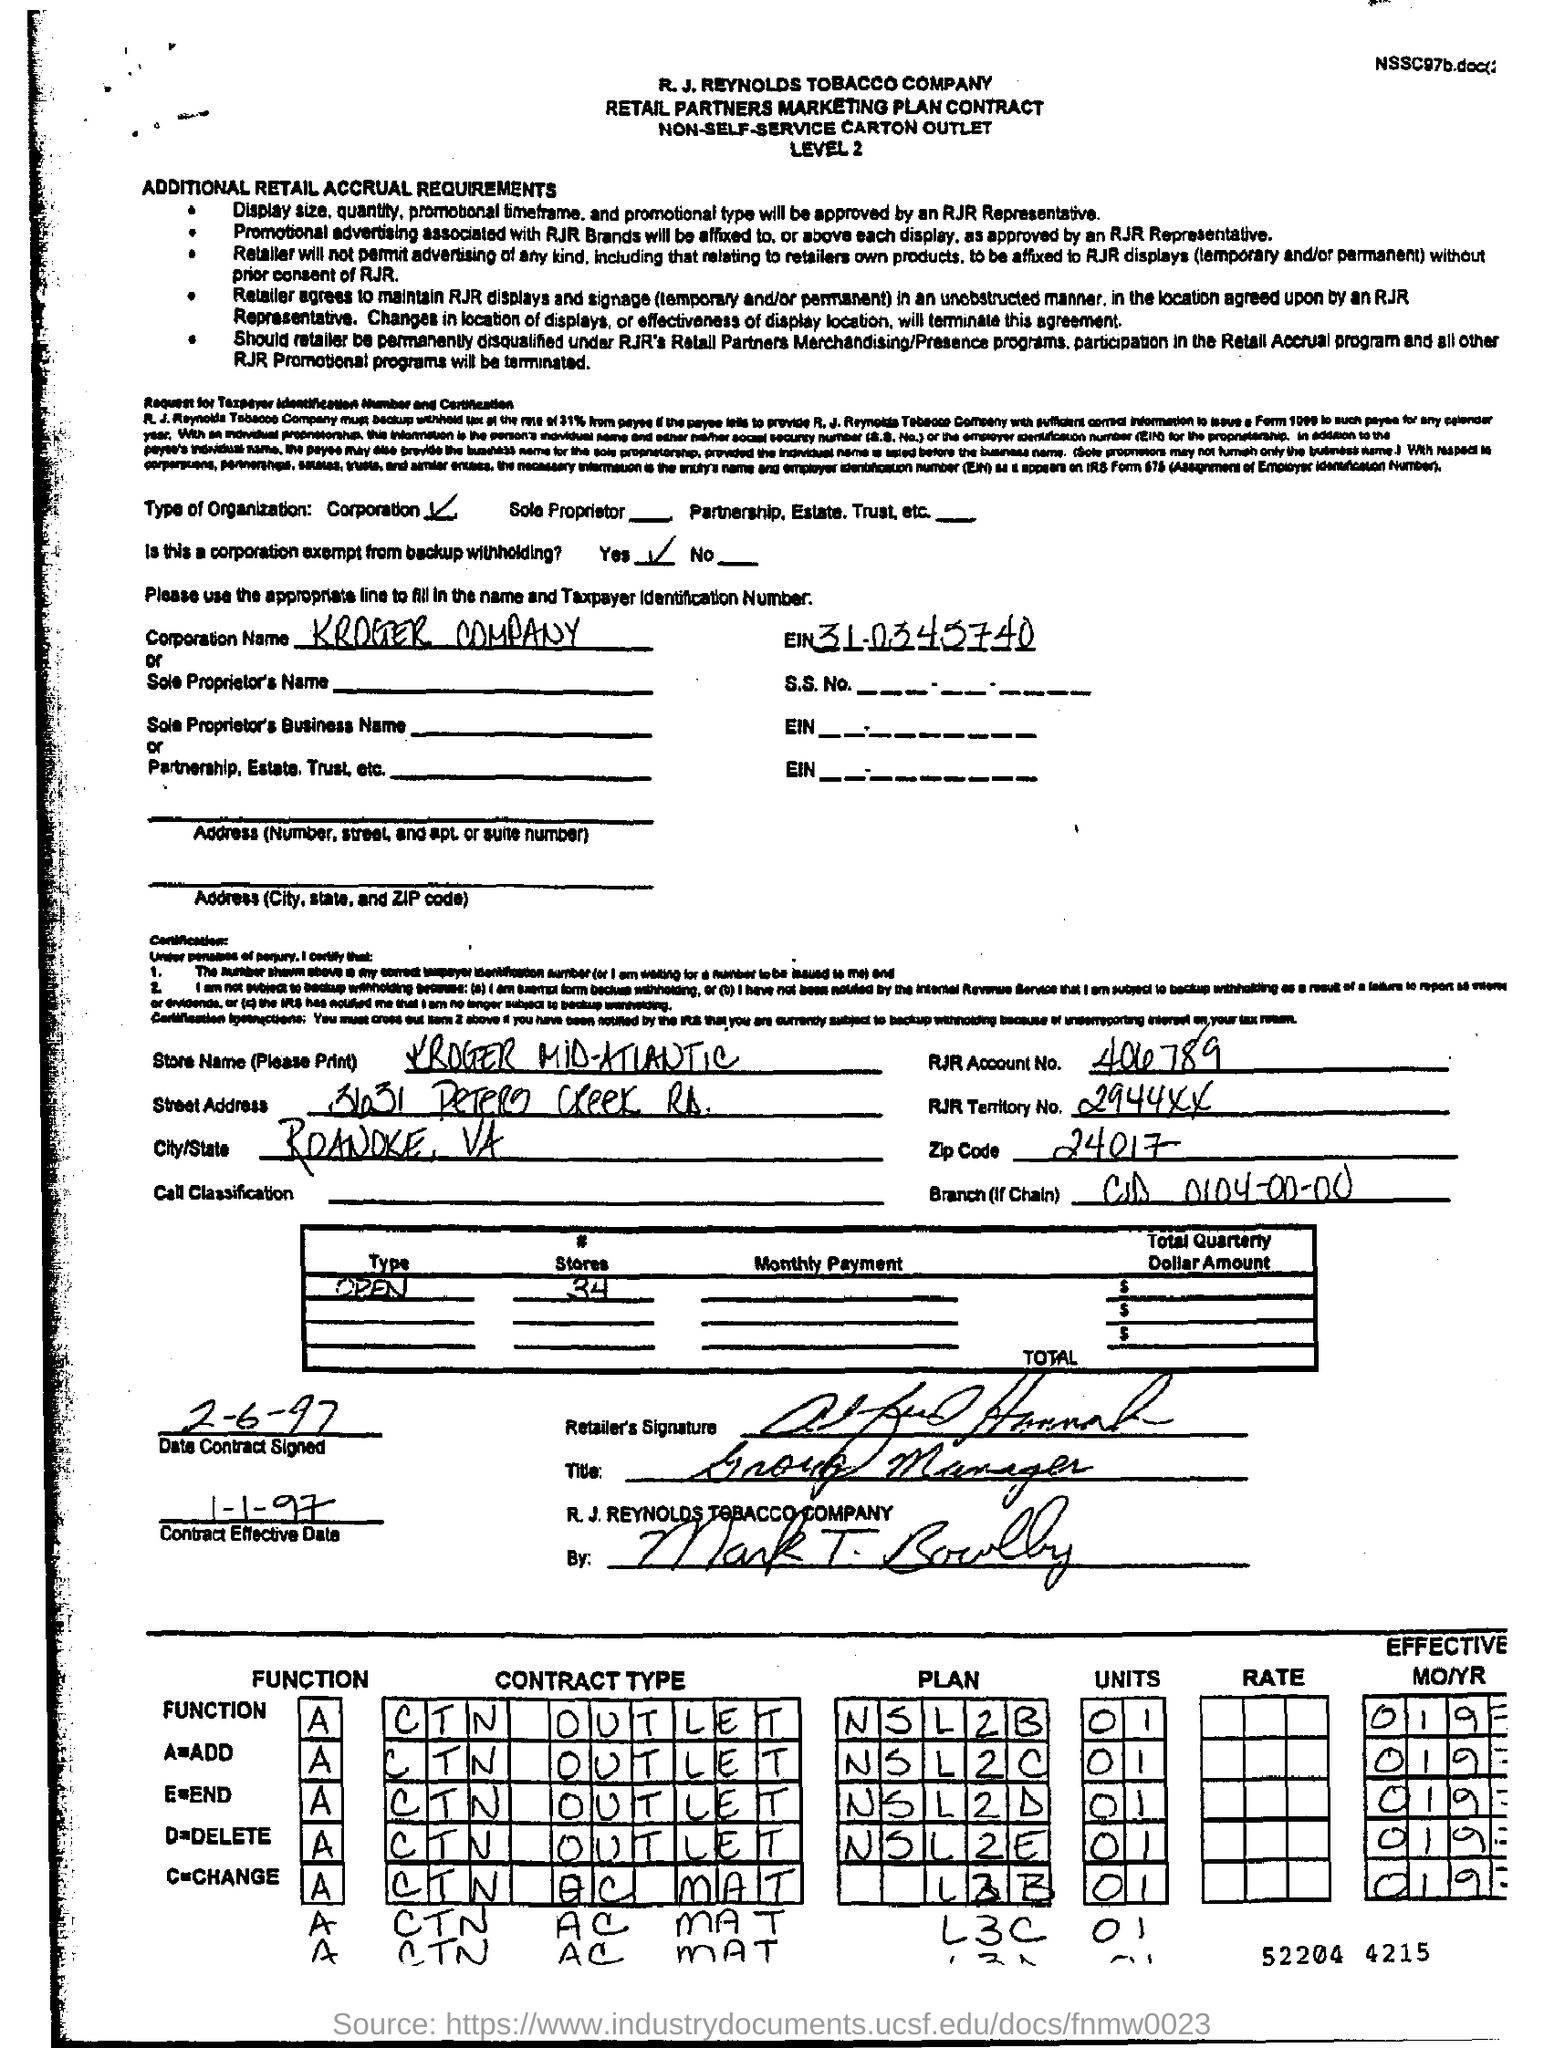Highlight a few significant elements in this photo. The function A is unknown. An add function has been defined, but its purpose or intended use is unclear. What is the zip code? It is 24017. The inquiry requests the account number for RJR, which is 406789. Please mention the effective date of the contract, which is January 1st, 1997. The entity is exempt from backup withholding as per the answer provided. 